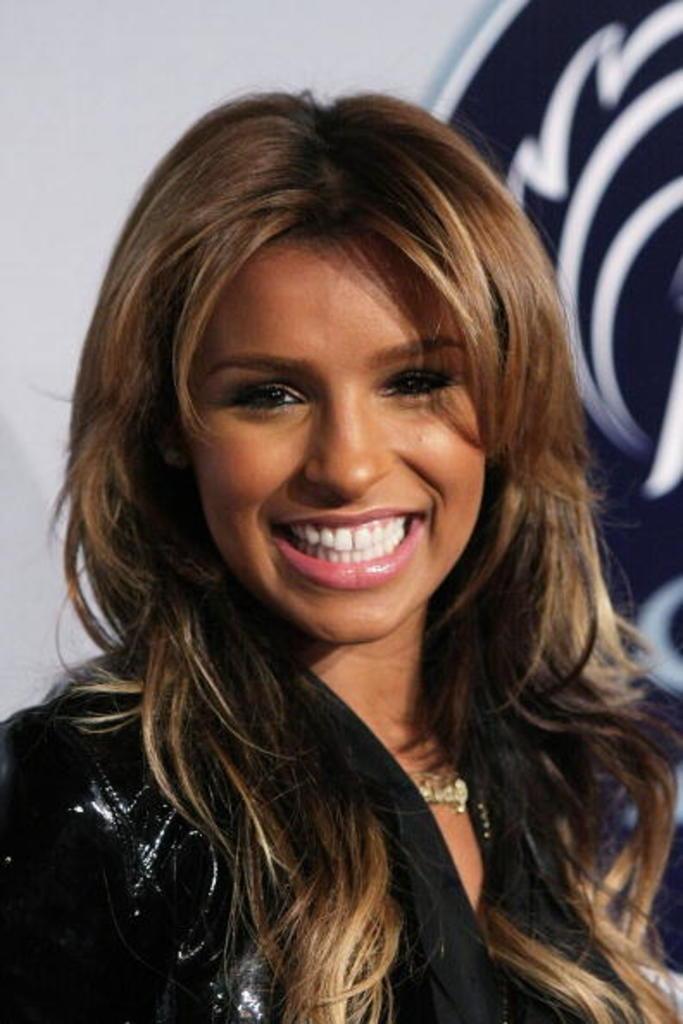In one or two sentences, can you explain what this image depicts? In this image I can see a person is smiling and wearing black color dress. Background is in white and black color. 